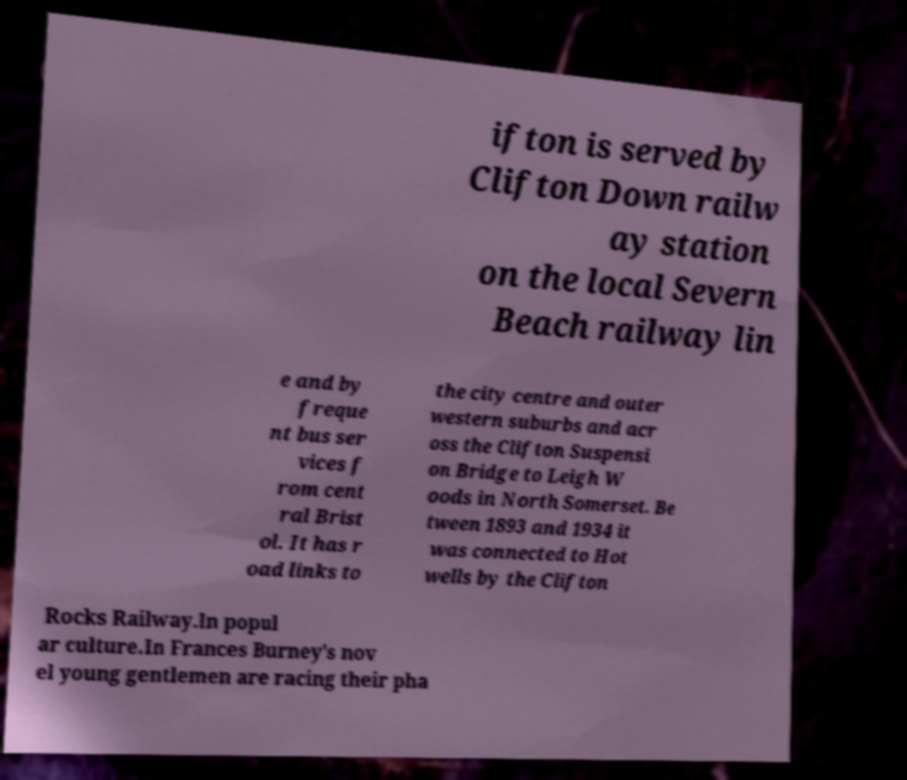Can you read and provide the text displayed in the image?This photo seems to have some interesting text. Can you extract and type it out for me? ifton is served by Clifton Down railw ay station on the local Severn Beach railway lin e and by freque nt bus ser vices f rom cent ral Brist ol. It has r oad links to the city centre and outer western suburbs and acr oss the Clifton Suspensi on Bridge to Leigh W oods in North Somerset. Be tween 1893 and 1934 it was connected to Hot wells by the Clifton Rocks Railway.In popul ar culture.In Frances Burney's nov el young gentlemen are racing their pha 